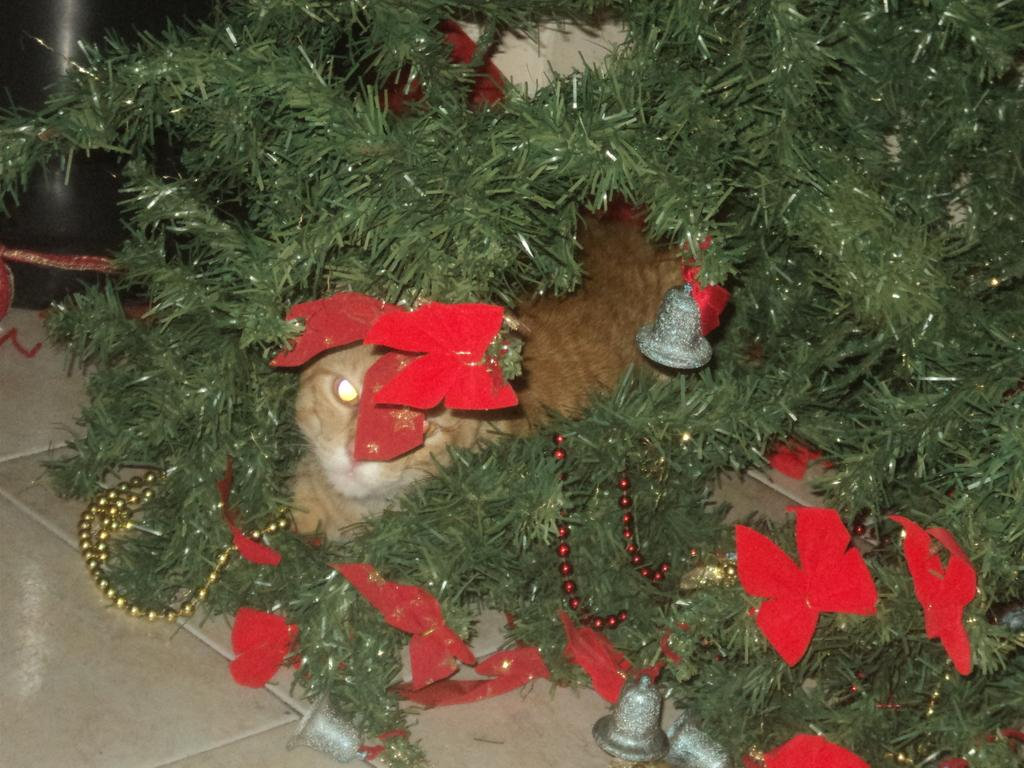What type of tree is decorated in the image? There is a decorated Christmas tree in the image. What other living creature can be seen in the image? There is a cat visible in the image. What surface is the tree and cat standing on in the image? The floor is present in the image. What scent does the cat emit in the image? There is no information about the scent of the cat in the image. 